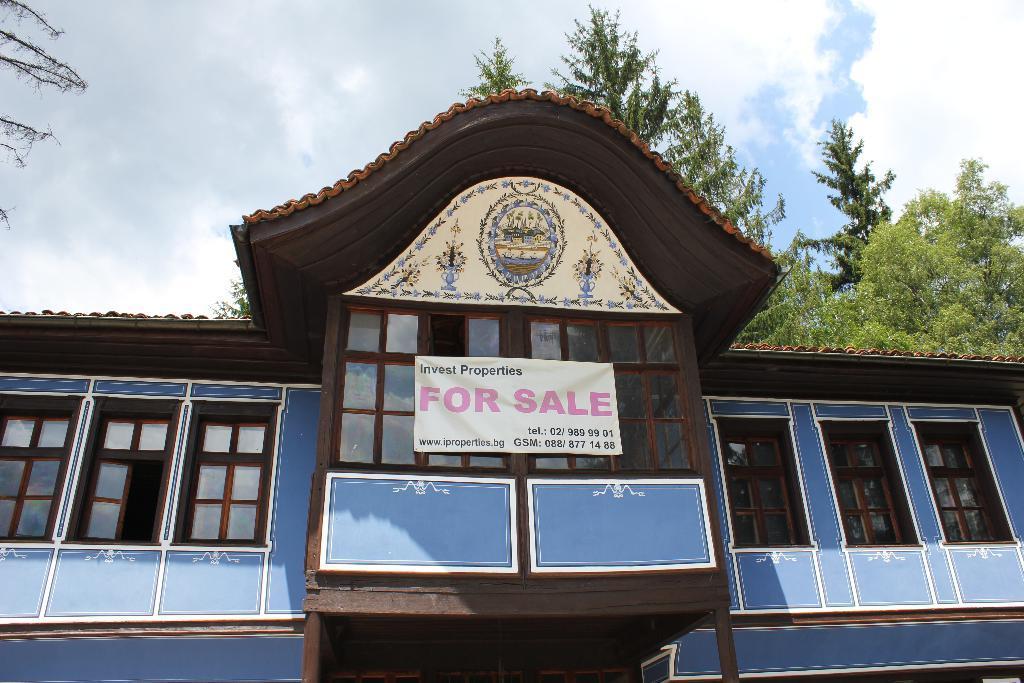In one or two sentences, can you explain what this image depicts? In this picture we can see a building in the front, in the background there are trees, we can see a banner and windows of this building, there is the sky and clouds at the top of the picture. 